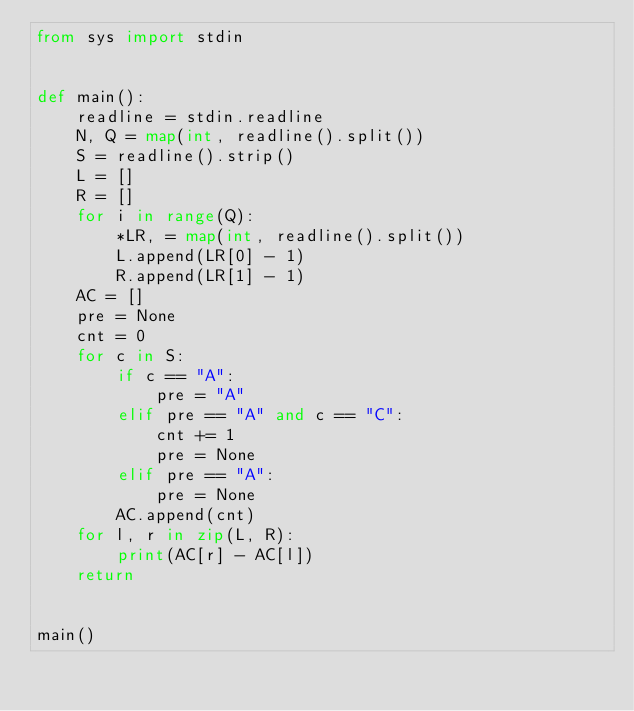<code> <loc_0><loc_0><loc_500><loc_500><_Python_>from sys import stdin


def main():
    readline = stdin.readline
    N, Q = map(int, readline().split())
    S = readline().strip()
    L = []
    R = []
    for i in range(Q):
        *LR, = map(int, readline().split())
        L.append(LR[0] - 1)
        R.append(LR[1] - 1)
    AC = []
    pre = None
    cnt = 0
    for c in S:
        if c == "A":
            pre = "A"
        elif pre == "A" and c == "C":
            cnt += 1
            pre = None
        elif pre == "A":
            pre = None
        AC.append(cnt)
    for l, r in zip(L, R):
        print(AC[r] - AC[l])
    return


main()
</code> 